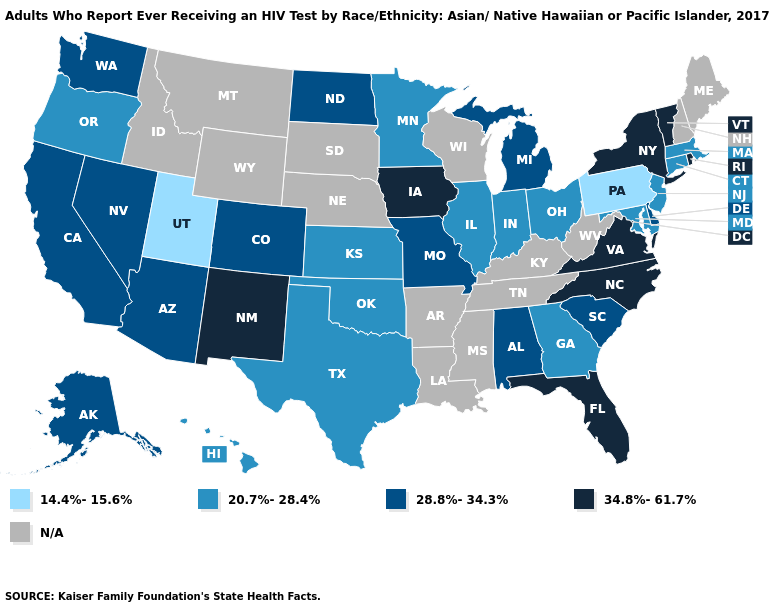What is the lowest value in states that border Indiana?
Write a very short answer. 20.7%-28.4%. Name the states that have a value in the range 28.8%-34.3%?
Short answer required. Alabama, Alaska, Arizona, California, Colorado, Delaware, Michigan, Missouri, Nevada, North Dakota, South Carolina, Washington. Which states hav the highest value in the West?
Concise answer only. New Mexico. Among the states that border Wisconsin , which have the lowest value?
Keep it brief. Illinois, Minnesota. Does Indiana have the highest value in the USA?
Keep it brief. No. What is the lowest value in the South?
Short answer required. 20.7%-28.4%. What is the value of Arkansas?
Answer briefly. N/A. Does Arizona have the lowest value in the West?
Short answer required. No. What is the value of New York?
Write a very short answer. 34.8%-61.7%. What is the highest value in states that border New Hampshire?
Short answer required. 34.8%-61.7%. Which states have the lowest value in the USA?
Keep it brief. Pennsylvania, Utah. What is the lowest value in states that border Oklahoma?
Short answer required. 20.7%-28.4%. Among the states that border Kentucky , which have the highest value?
Quick response, please. Virginia. Which states have the highest value in the USA?
Give a very brief answer. Florida, Iowa, New Mexico, New York, North Carolina, Rhode Island, Vermont, Virginia. 